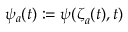<formula> <loc_0><loc_0><loc_500><loc_500>{ \psi _ { a } ( t ) \colon = \psi ( { \zeta } _ { a } ( t ) , t ) }</formula> 